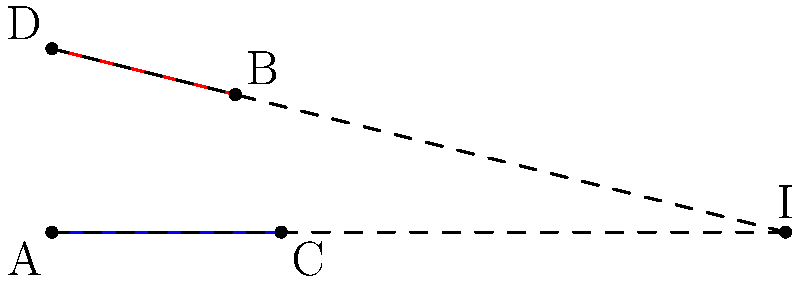Two roads intersect on a 2D plane as shown in the diagram. Road AC is represented by the line $y = \frac{3}{4}x$, and road DB is represented by the line $y = -\frac{4}{5}x + 8$. Calculate the shortest distance between these two roads. To find the shortest distance between the two intersecting roads, we need to:

1. Find the intersection point of the two roads.
2. Calculate the angle between the roads.
3. Use the sine formula to find the shortest distance.

Step 1: Find the intersection point
- Equate the two line equations:
  $$\frac{3}{4}x = -\frac{4}{5}x + 8$$
- Solve for x:
  $$\frac{3}{4}x + \frac{4}{5}x = 8$$
  $$\frac{31}{20}x = 8$$
  $$x = \frac{160}{31} \approx 5.16$$
- Substitute x back into either equation to find y:
  $$y = \frac{3}{4} \cdot \frac{160}{31} = \frac{120}{31} \approx 3.87$$
- Intersection point I: $(\frac{160}{31}, \frac{120}{31})$

Step 2: Calculate the angle between the roads
- Slope of AC: $m_1 = \frac{3}{4}$
- Slope of DB: $m_2 = -\frac{4}{5}$
- Angle formula: $\tan \theta = |\frac{m_1 - m_2}{1 + m_1m_2}|$
- Substituting:
  $$\tan \theta = |\frac{\frac{3}{4} - (-\frac{4}{5})}{1 + \frac{3}{4}(-\frac{4}{5})}| = |\frac{\frac{31}{20}}{1 - \frac{3}{5}}| = \frac{31}{8}$$
- $\theta = \arctan(\frac{31}{8}) \approx 1.32$ radians or 75.52°

Step 3: Use the sine formula
- Choose any point on one road, e.g., A(0,0)
- Distance from A to I:
  $$d = \sqrt{(\frac{160}{31})^2 + (\frac{120}{31})^2} \approx 6.45$$
- Shortest distance: $D = d \cdot \sin \theta$
- Substituting:
  $$D = 6.45 \cdot \sin(1.32) \approx 6.24$$

Therefore, the shortest distance between the two roads is approximately 6.24 units.
Answer: 6.24 units 